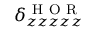<formula> <loc_0><loc_0><loc_500><loc_500>\delta _ { z z z z z } ^ { H O R }</formula> 